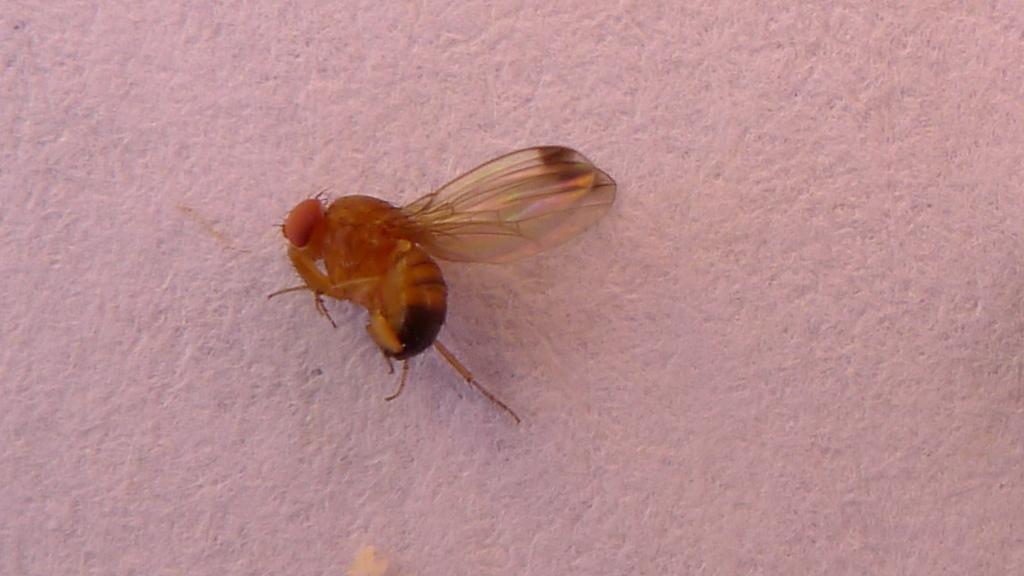Describe this image in one or two sentences. In this image I can see an insect and the insect is in brown and black color and I can see the white color background. 